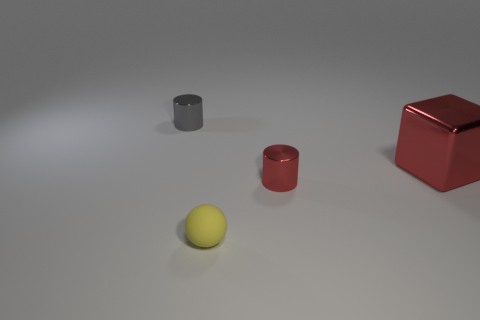Add 2 big red things. How many objects exist? 6 Subtract all balls. How many objects are left? 3 Add 4 red objects. How many red objects are left? 6 Add 4 gray shiny cylinders. How many gray shiny cylinders exist? 5 Subtract 0 cyan balls. How many objects are left? 4 Subtract all big green cylinders. Subtract all metallic cylinders. How many objects are left? 2 